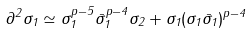<formula> <loc_0><loc_0><loc_500><loc_500>\partial ^ { 2 } \sigma _ { 1 } \simeq \sigma _ { 1 } ^ { p - 5 } \bar { \sigma } _ { 1 } ^ { p - 4 } \sigma _ { 2 } + \sigma _ { 1 } ( \sigma _ { 1 } \bar { \sigma } _ { 1 } ) ^ { p - 4 }</formula> 